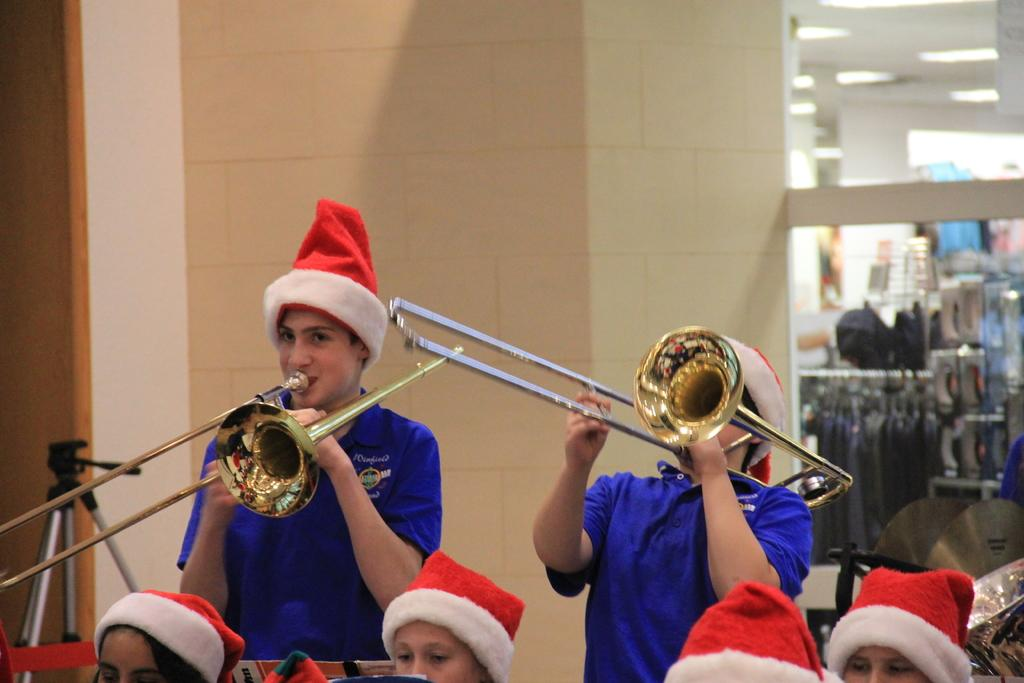Who is present in the image? There are children in the image. What are the children wearing? The children are wearing clothes and Santa caps. What else can be seen in the image besides the children? There are musical instruments, clothes, a light, a wall, and a stand visible in the image. What type of current can be seen flowing through the musical instruments in the image? There is no current visible in the image; the musical instruments are not connected to any power source. 